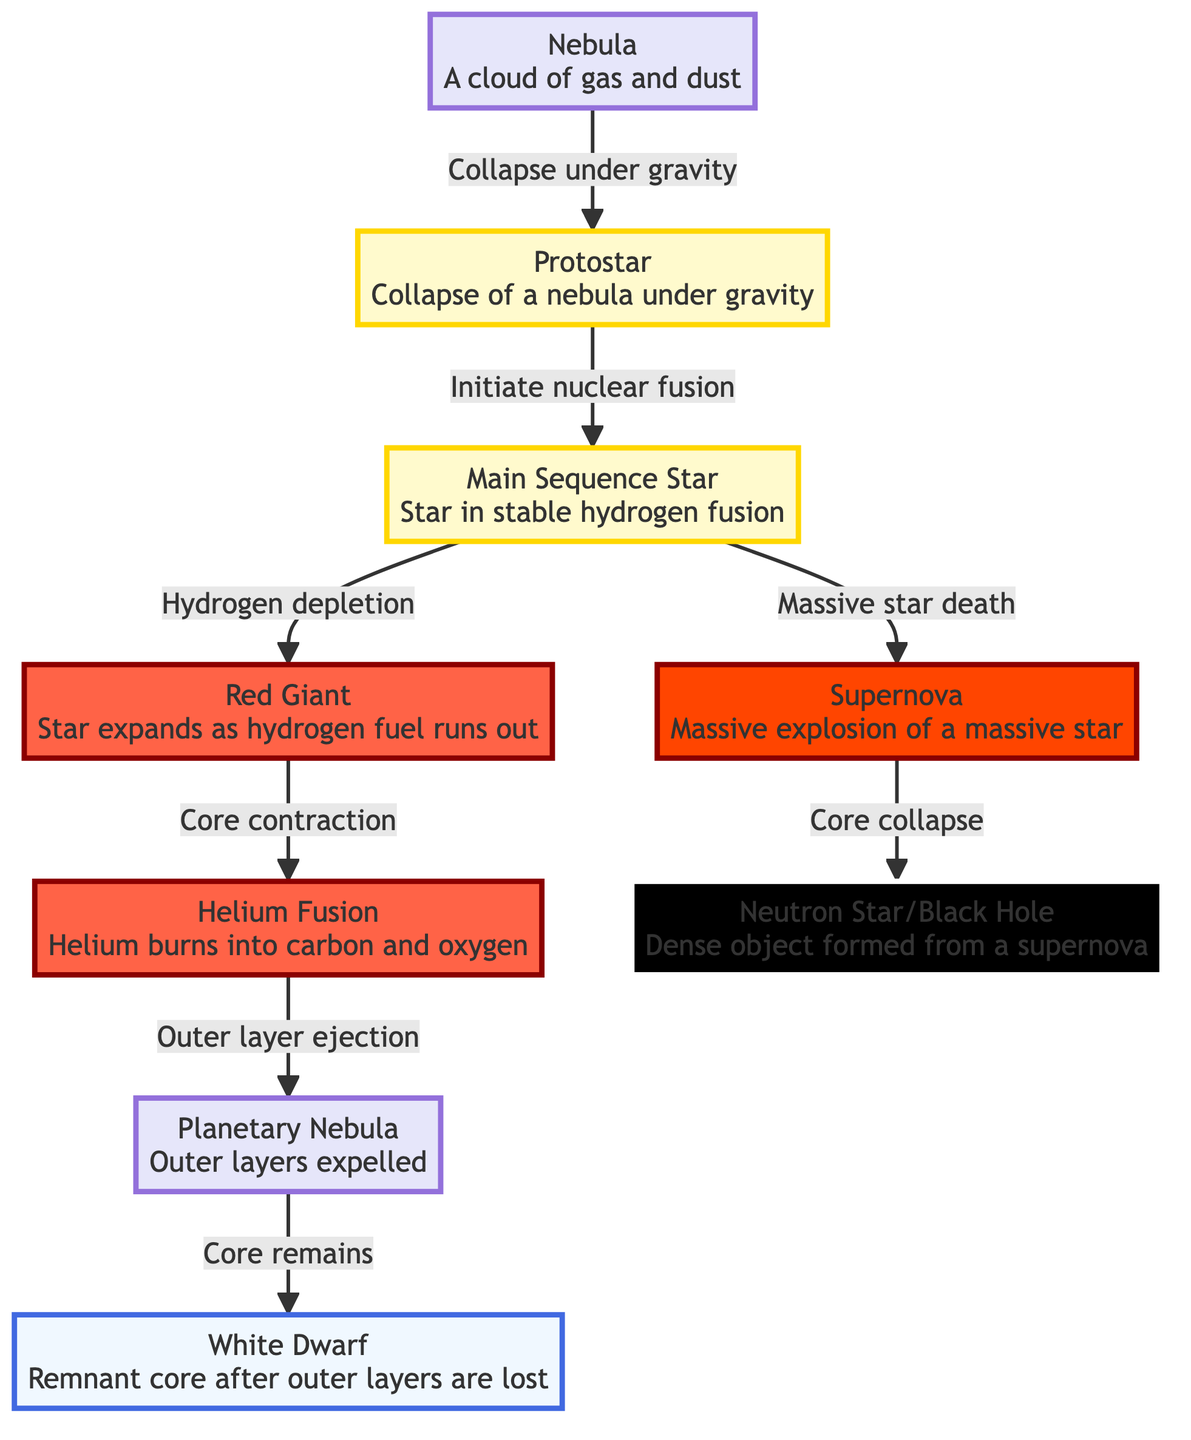What is the initial stage of a star's lifecycle? The diagram shows that the lifecycle of a star begins with a nebula, which is a cloud of gas and dust.
Answer: Nebula How many main stages are there in the lifecycle? The diagram lists seven main stages in the lifecycle of a star. These are: Nebula, Protostar, Main Sequence Star, Red Giant, Helium Fusion, Planetary Nebula, and either White Dwarf or Supernova.
Answer: Seven What happens to a main sequence star when its hydrogen is depleted? The diagram indicates that when a main sequence star depletes its hydrogen, it evolves into a red giant.
Answer: Red Giant What is formed after the supernova explosion of a massive star? Upon the completion of the supernova, the diagram illustrates that a neutron star or a black hole is formed as a dense object from the remnants of the explosion.
Answer: Neutron Star/Black Hole What process initiates the transition from a nebula to a protostar? The flowchart indicates that the collapse of a nebula under gravity initiates the formation of a protostar.
Answer: Collapse under gravity What occurs after the helium fusion stage in the star's lifecycle? According to the diagram, following the helium fusion stage, the outer layers of the star are ejected, resulting in a planetary nebula.
Answer: Planetary Nebula Which stage directly leads to the creation of a white dwarf? The diagram shows that after the planetary nebula stage, the core remains and evolves into a white dwarf.
Answer: White Dwarf What type of star results from the death of a main sequence star? The flowchart specifies that a supernova is the outcome of the death of a massive main sequence star.
Answer: Supernova 